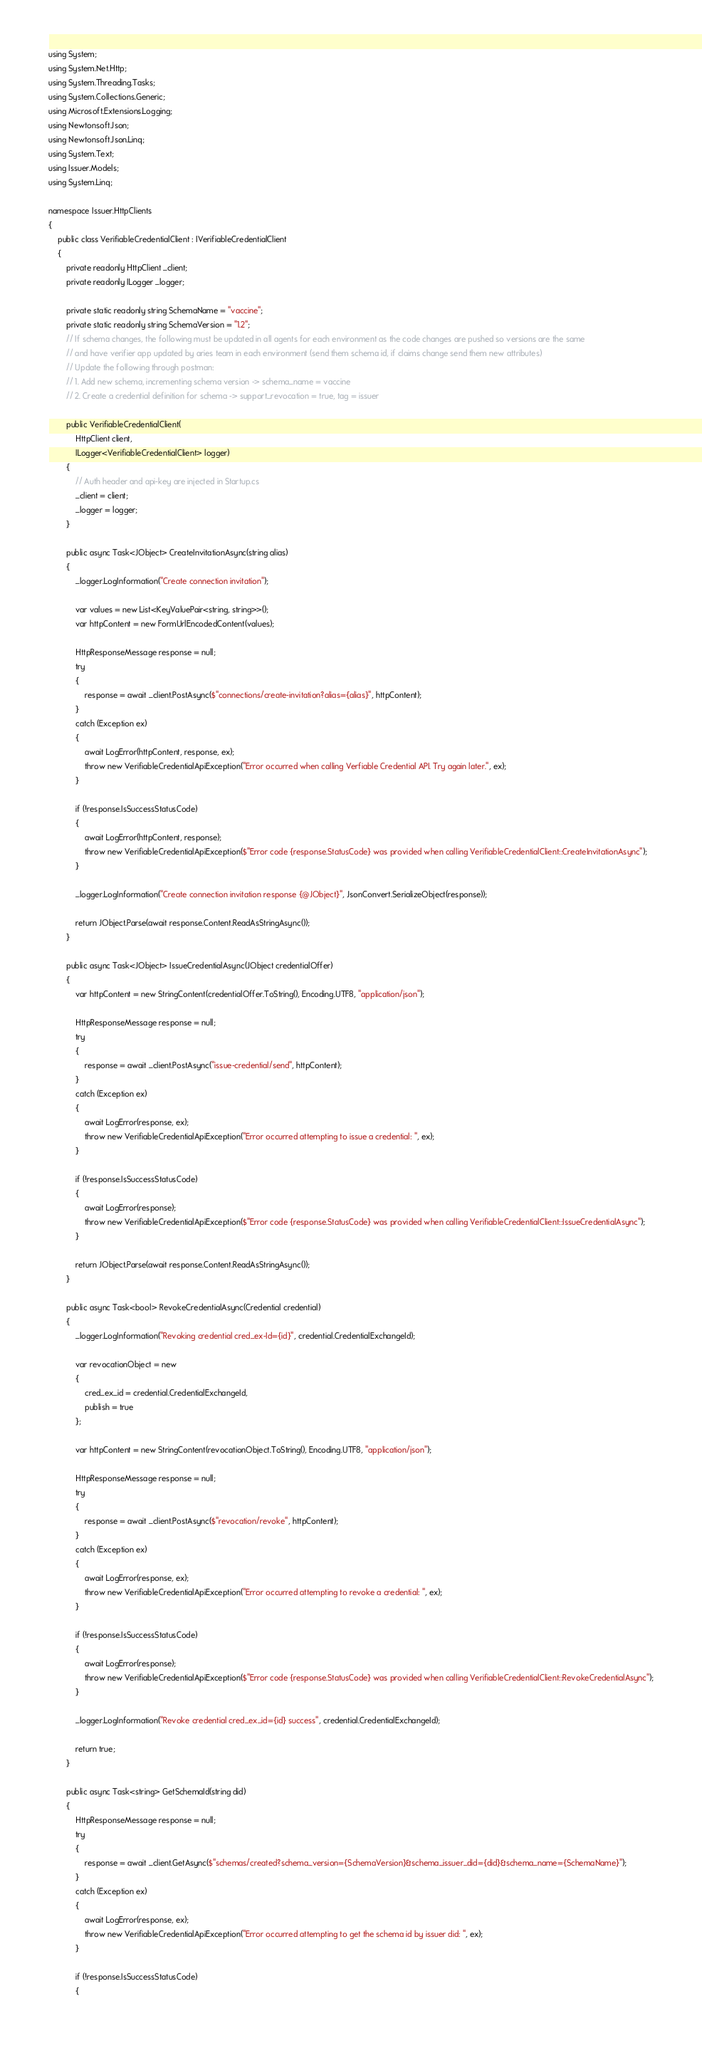Convert code to text. <code><loc_0><loc_0><loc_500><loc_500><_C#_>using System;
using System.Net.Http;
using System.Threading.Tasks;
using System.Collections.Generic;
using Microsoft.Extensions.Logging;
using Newtonsoft.Json;
using Newtonsoft.Json.Linq;
using System.Text;
using Issuer.Models;
using System.Linq;

namespace Issuer.HttpClients
{
    public class VerifiableCredentialClient : IVerifiableCredentialClient
    {
        private readonly HttpClient _client;
        private readonly ILogger _logger;

        private static readonly string SchemaName = "vaccine";
        private static readonly string SchemaVersion = "1.2";
        // If schema changes, the following must be updated in all agents for each environment as the code changes are pushed so versions are the same
        // and have verifier app updated by aries team in each environment (send them schema id, if claims change send them new attributes)
        // Update the following through postman:
        // 1. Add new schema, incrementing schema version -> schema_name = vaccine
        // 2. Create a credential definition for schema -> support_revocation = true, tag = issuer

        public VerifiableCredentialClient(
            HttpClient client,
            ILogger<VerifiableCredentialClient> logger)
        {
            // Auth header and api-key are injected in Startup.cs
            _client = client;
            _logger = logger;
        }

        public async Task<JObject> CreateInvitationAsync(string alias)
        {
            _logger.LogInformation("Create connection invitation");

            var values = new List<KeyValuePair<string, string>>();
            var httpContent = new FormUrlEncodedContent(values);

            HttpResponseMessage response = null;
            try
            {
                response = await _client.PostAsync($"connections/create-invitation?alias={alias}", httpContent);
            }
            catch (Exception ex)
            {
                await LogError(httpContent, response, ex);
                throw new VerifiableCredentialApiException("Error occurred when calling Verfiable Credential API. Try again later.", ex);
            }

            if (!response.IsSuccessStatusCode)
            {
                await LogError(httpContent, response);
                throw new VerifiableCredentialApiException($"Error code {response.StatusCode} was provided when calling VerifiableCredentialClient::CreateInvitationAsync");
            }

            _logger.LogInformation("Create connection invitation response {@JObject}", JsonConvert.SerializeObject(response));

            return JObject.Parse(await response.Content.ReadAsStringAsync());
        }

        public async Task<JObject> IssueCredentialAsync(JObject credentialOffer)
        {
            var httpContent = new StringContent(credentialOffer.ToString(), Encoding.UTF8, "application/json");

            HttpResponseMessage response = null;
            try
            {
                response = await _client.PostAsync("issue-credential/send", httpContent);
            }
            catch (Exception ex)
            {
                await LogError(response, ex);
                throw new VerifiableCredentialApiException("Error occurred attempting to issue a credential: ", ex);
            }

            if (!response.IsSuccessStatusCode)
            {
                await LogError(response);
                throw new VerifiableCredentialApiException($"Error code {response.StatusCode} was provided when calling VerifiableCredentialClient::IssueCredentialAsync");
            }

            return JObject.Parse(await response.Content.ReadAsStringAsync());
        }

        public async Task<bool> RevokeCredentialAsync(Credential credential)
        {
            _logger.LogInformation("Revoking credential cred_ex-Id={id}", credential.CredentialExchangeId);

            var revocationObject = new
            {
                cred_ex_id = credential.CredentialExchangeId,
                publish = true
            };

            var httpContent = new StringContent(revocationObject.ToString(), Encoding.UTF8, "application/json");

            HttpResponseMessage response = null;
            try
            {
                response = await _client.PostAsync($"revocation/revoke", httpContent);
            }
            catch (Exception ex)
            {
                await LogError(response, ex);
                throw new VerifiableCredentialApiException("Error occurred attempting to revoke a credential: ", ex);
            }

            if (!response.IsSuccessStatusCode)
            {
                await LogError(response);
                throw new VerifiableCredentialApiException($"Error code {response.StatusCode} was provided when calling VerifiableCredentialClient::RevokeCredentialAsync");
            }

            _logger.LogInformation("Revoke credential cred_ex_id={id} success", credential.CredentialExchangeId);

            return true;
        }

        public async Task<string> GetSchemaId(string did)
        {
            HttpResponseMessage response = null;
            try
            {
                response = await _client.GetAsync($"schemas/created?schema_version={SchemaVersion}&schema_issuer_did={did}&schema_name={SchemaName}");
            }
            catch (Exception ex)
            {
                await LogError(response, ex);
                throw new VerifiableCredentialApiException("Error occurred attempting to get the schema id by issuer did: ", ex);
            }

            if (!response.IsSuccessStatusCode)
            {</code> 